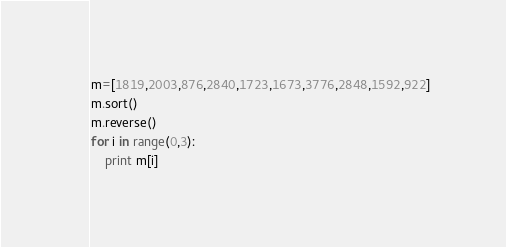Convert code to text. <code><loc_0><loc_0><loc_500><loc_500><_Python_>m=[1819,2003,876,2840,1723,1673,3776,2848,1592,922]
m.sort()
m.reverse()
for i in range(0,3):
	print m[i]</code> 